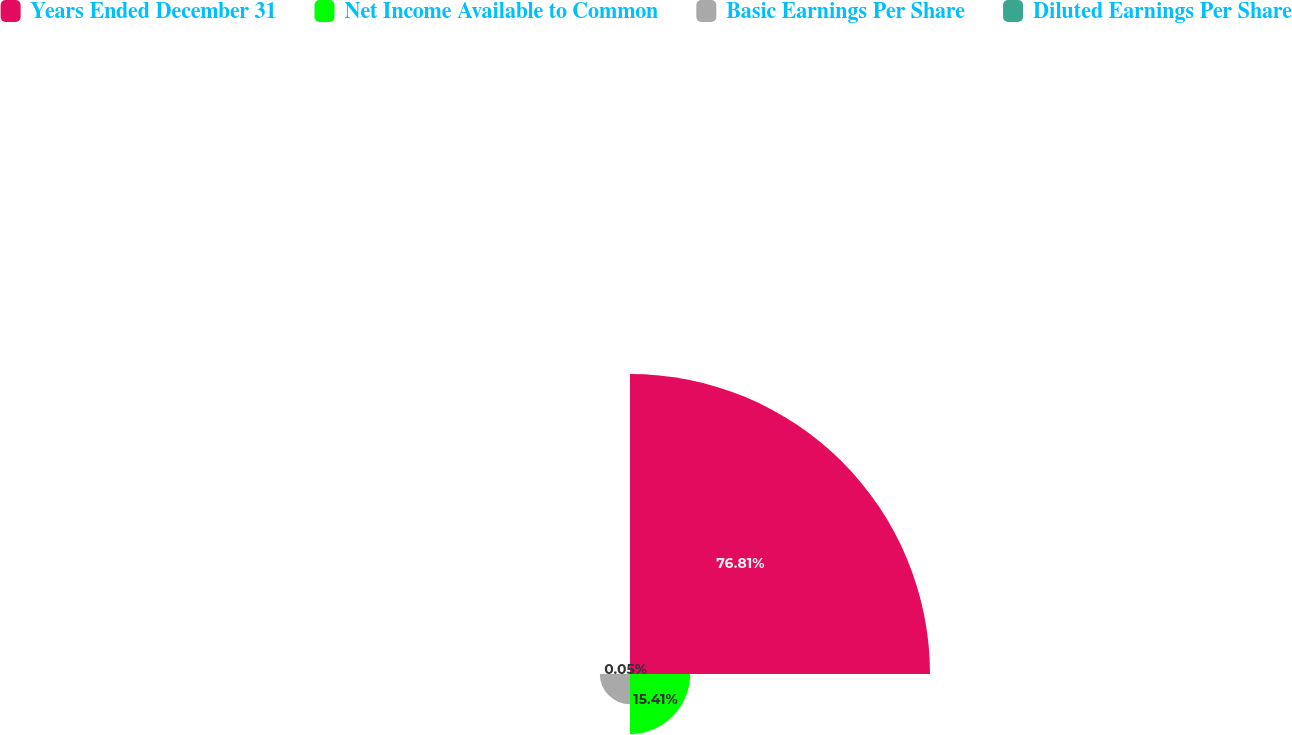<chart> <loc_0><loc_0><loc_500><loc_500><pie_chart><fcel>Years Ended December 31<fcel>Net Income Available to Common<fcel>Basic Earnings Per Share<fcel>Diluted Earnings Per Share<nl><fcel>76.81%<fcel>15.41%<fcel>7.73%<fcel>0.05%<nl></chart> 